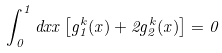<formula> <loc_0><loc_0><loc_500><loc_500>\int _ { 0 } ^ { 1 } d x x \left [ g _ { 1 } ^ { k } ( x ) + 2 g _ { 2 } ^ { k } ( x ) \right ] = 0</formula> 